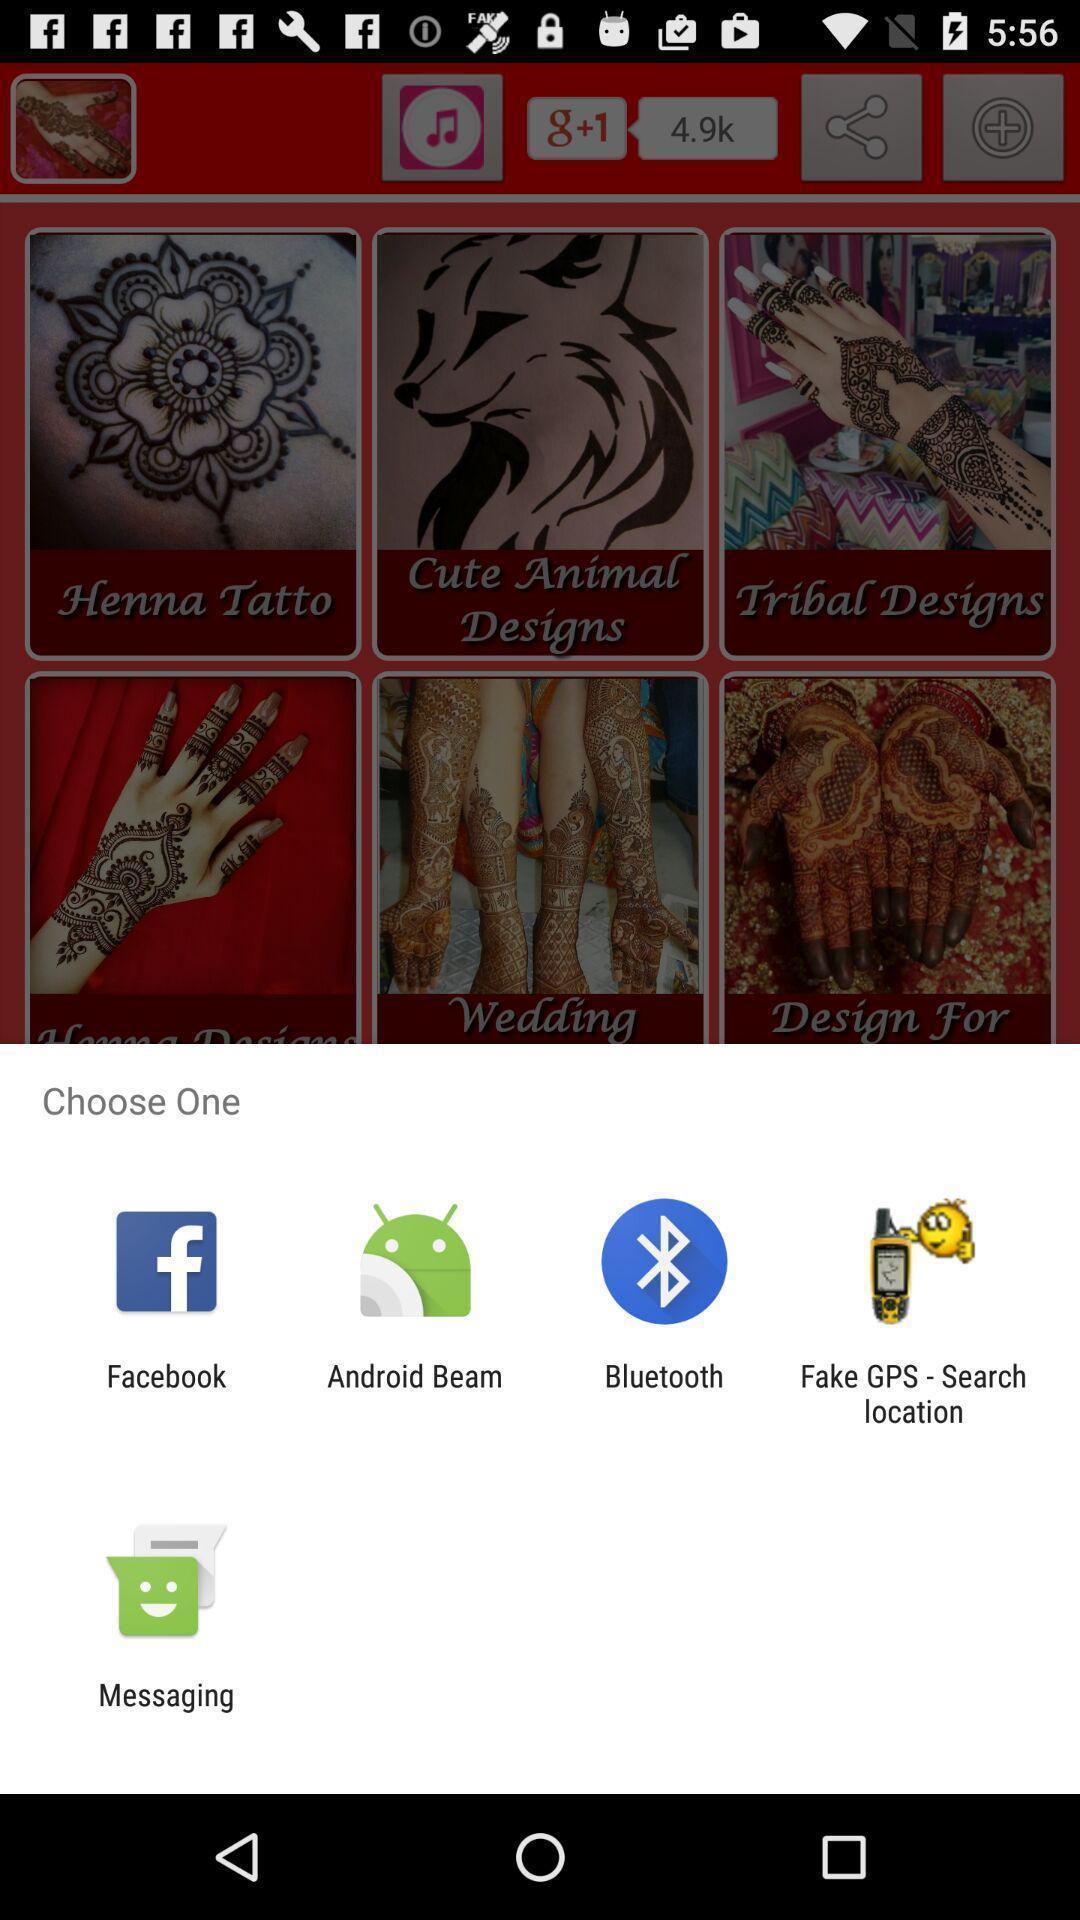Tell me what you see in this picture. Pop up displaying multiple icons. 